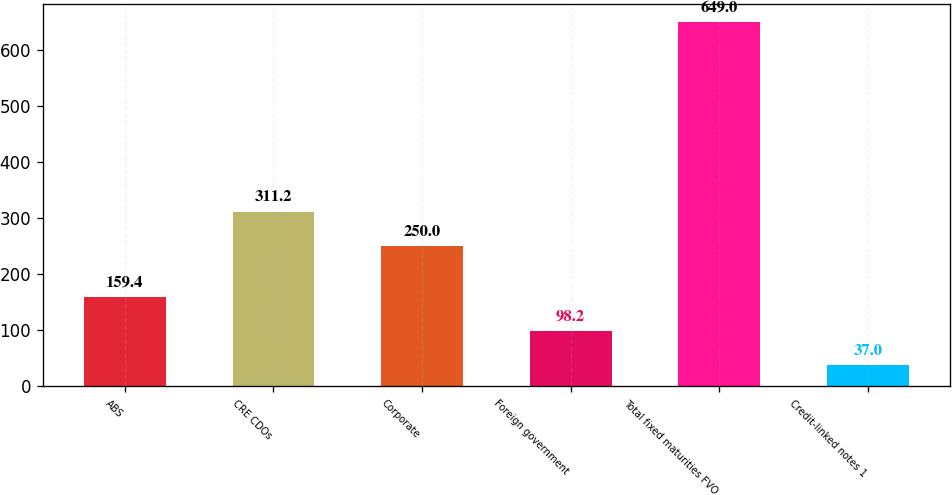<chart> <loc_0><loc_0><loc_500><loc_500><bar_chart><fcel>ABS<fcel>CRE CDOs<fcel>Corporate<fcel>Foreign government<fcel>Total fixed maturities FVO<fcel>Credit-linked notes 1<nl><fcel>159.4<fcel>311.2<fcel>250<fcel>98.2<fcel>649<fcel>37<nl></chart> 